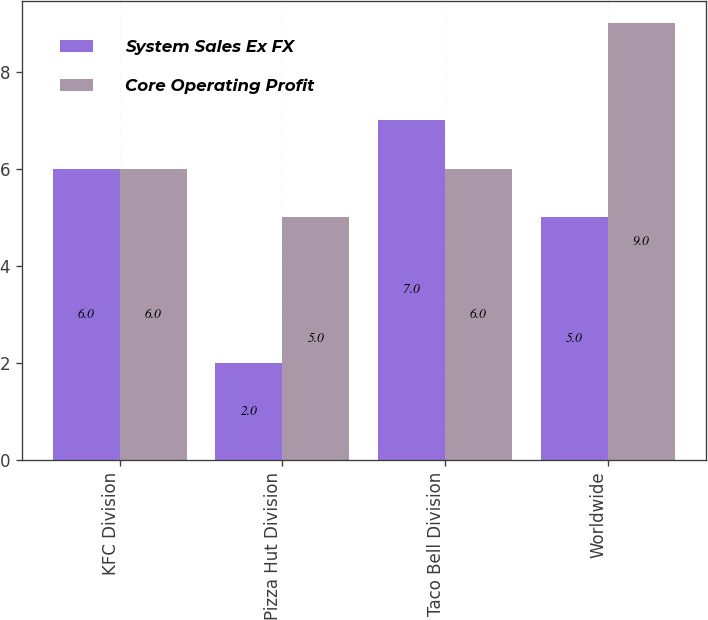<chart> <loc_0><loc_0><loc_500><loc_500><stacked_bar_chart><ecel><fcel>KFC Division<fcel>Pizza Hut Division<fcel>Taco Bell Division<fcel>Worldwide<nl><fcel>System Sales Ex FX<fcel>6<fcel>2<fcel>7<fcel>5<nl><fcel>Core Operating Profit<fcel>6<fcel>5<fcel>6<fcel>9<nl></chart> 